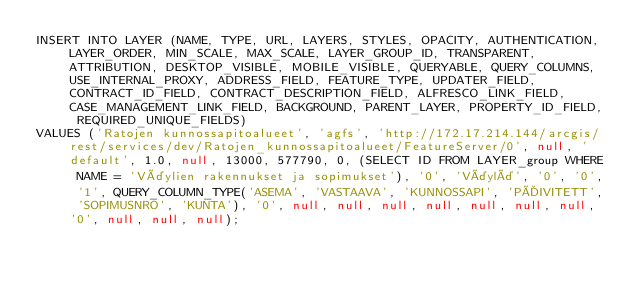<code> <loc_0><loc_0><loc_500><loc_500><_SQL_>INSERT INTO LAYER (NAME, TYPE, URL, LAYERS, STYLES, OPACITY, AUTHENTICATION, LAYER_ORDER, MIN_SCALE, MAX_SCALE, LAYER_GROUP_ID, TRANSPARENT, ATTRIBUTION, DESKTOP_VISIBLE, MOBILE_VISIBLE, QUERYABLE, QUERY_COLUMNS, USE_INTERNAL_PROXY, ADDRESS_FIELD, FEATURE_TYPE, UPDATER_FIELD, CONTRACT_ID_FIELD, CONTRACT_DESCRIPTION_FIELD, ALFRESCO_LINK_FIELD, CASE_MANAGEMENT_LINK_FIELD, BACKGROUND, PARENT_LAYER, PROPERTY_ID_FIELD, REQUIRED_UNIQUE_FIELDS) 
VALUES ('Ratojen kunnossapitoalueet', 'agfs', 'http://172.17.214.144/arcgis/rest/services/dev/Ratojen_kunnossapitoalueet/FeatureServer/0', null, 'default', 1.0, null, 13000, 577790, 0, (SELECT ID FROM LAYER_group WHERE NAME = 'Väylien rakennukset ja sopimukset'), '0', 'Väylä', '0', '0', '1', QUERY_COLUMN_TYPE('ASEMA', 'VASTAAVA', 'KUNNOSSAPI', 'PÄIVITETT', 'SOPIMUSNRO', 'KUNTA'), '0', null, null, null, null, null, null, null, '0', null, null, null);
</code> 